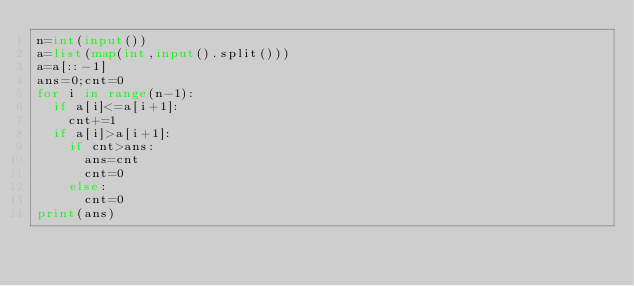Convert code to text. <code><loc_0><loc_0><loc_500><loc_500><_Python_>n=int(input())
a=list(map(int,input().split()))
a=a[::-1]
ans=0;cnt=0
for i in range(n-1):
  if a[i]<=a[i+1]:
    cnt+=1
  if a[i]>a[i+1]:
    if cnt>ans:
      ans=cnt
      cnt=0
    else:
      cnt=0
print(ans)</code> 